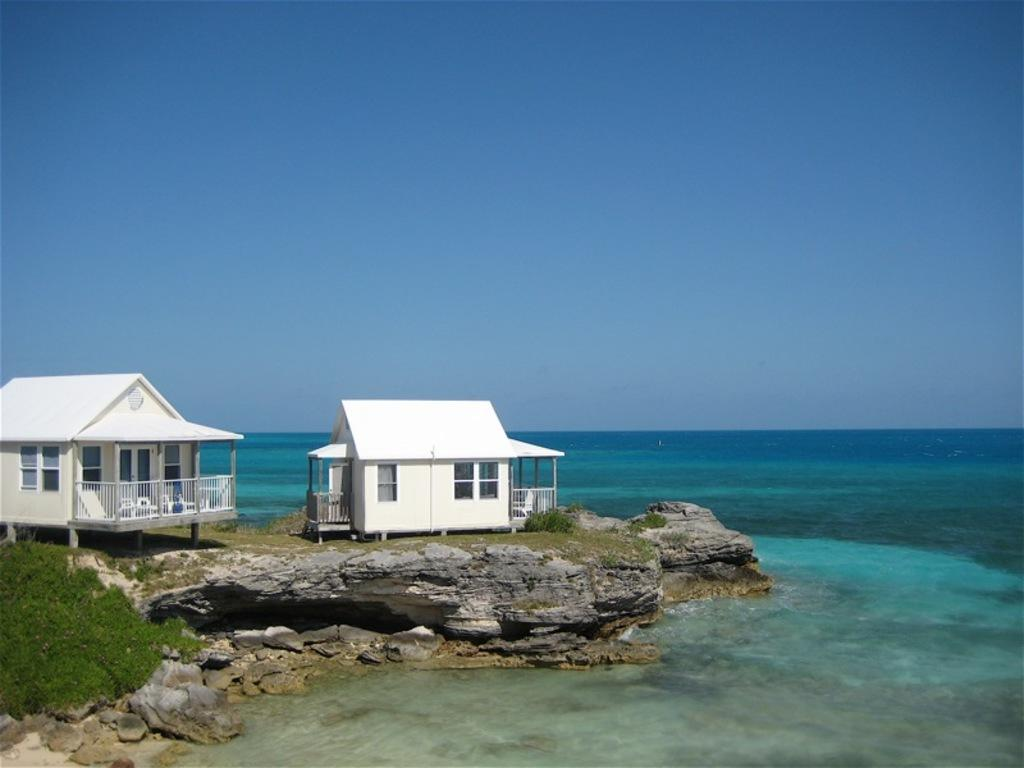What is the main element present in the image? There is water in the image. What structures can be seen on the left side of the image? There are two shacks on the left side of the image. What features do the shacks have? The shacks have windows and doors. What type of vegetation is present in the image? There is grass in the image. What can be seen in the background of the image? The sky is visible in the background of the image. What type of root can be seen growing from the shacks in the image? There are no roots growing from the shacks in the image. Is there an alley between the two shacks in the image? The image does not show an alley between the two shacks; it only shows the shacks and their surroundings. 